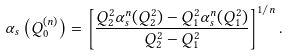<formula> <loc_0><loc_0><loc_500><loc_500>\alpha _ { s } \left ( Q _ { 0 } ^ { ( n ) } \right ) = \left [ \frac { Q _ { 2 } ^ { 2 } \alpha _ { s } ^ { n } ( Q _ { 2 } ^ { 2 } ) - Q _ { 1 } ^ { 2 } \alpha _ { s } ^ { n } ( Q _ { 1 } ^ { 2 } ) } { Q _ { 2 } ^ { 2 } - Q _ { 1 } ^ { 2 } } \right ] ^ { 1 / n } .</formula> 